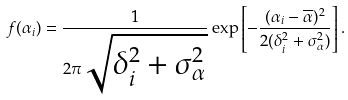<formula> <loc_0><loc_0><loc_500><loc_500>f ( \alpha _ { i } ) = \frac { 1 } { 2 \pi \sqrt { \delta _ { i } ^ { 2 } + \sigma _ { \alpha } ^ { 2 } } } \exp \left [ - \frac { ( \alpha _ { i } - \overline { \alpha } ) ^ { 2 } } { 2 ( \delta _ { i } ^ { 2 } + \sigma _ { \alpha } ^ { 2 } ) } \right ] .</formula> 